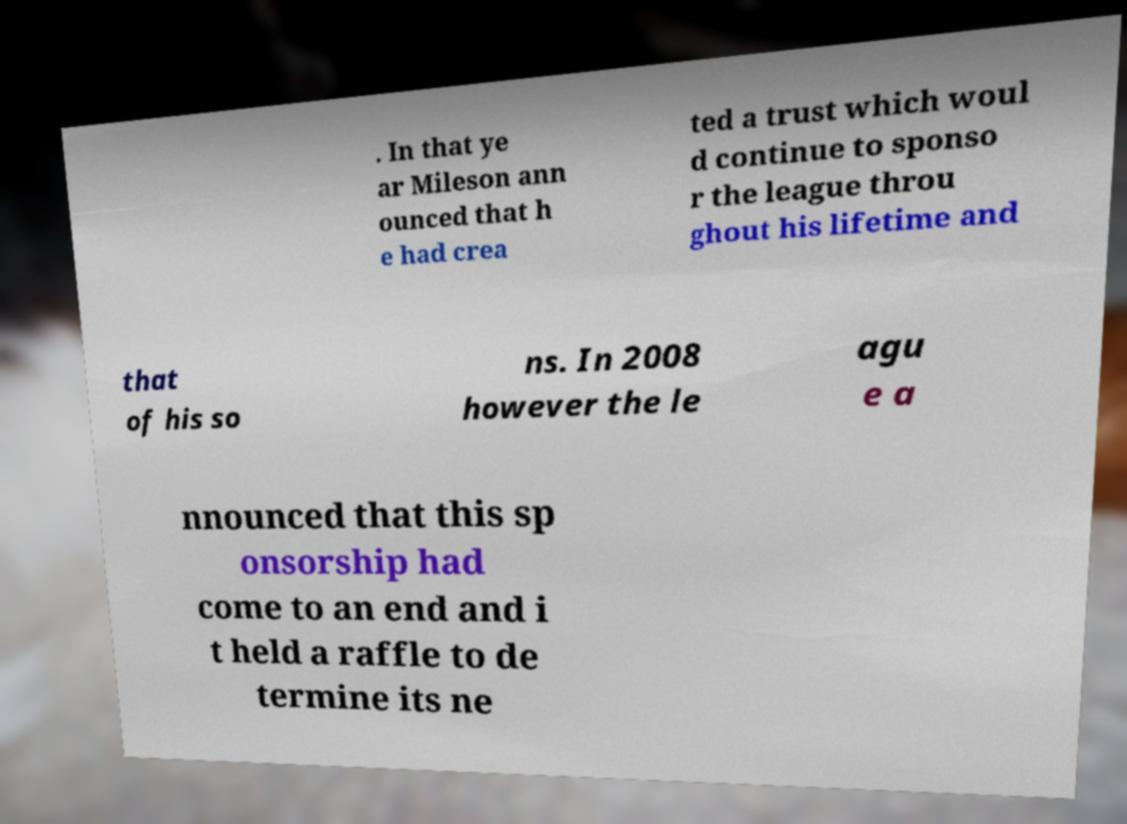Please identify and transcribe the text found in this image. . In that ye ar Mileson ann ounced that h e had crea ted a trust which woul d continue to sponso r the league throu ghout his lifetime and that of his so ns. In 2008 however the le agu e a nnounced that this sp onsorship had come to an end and i t held a raffle to de termine its ne 